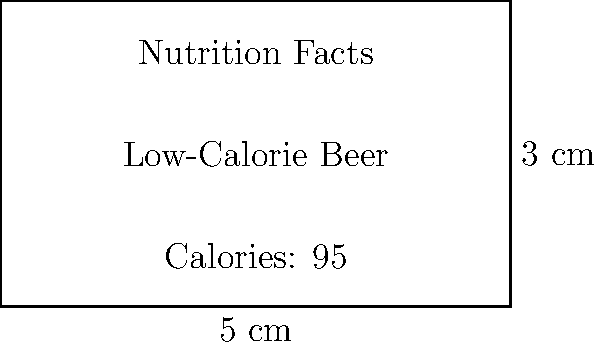A health-conscious bar-goer notices a new low-calorie beer with a rectangular nutrition label. The label measures 5 cm in width and 3 cm in height. What is the area of the nutrition label in square centimeters? To find the area of a rectangle, we multiply its length by its width. In this case:

1. Width of the label = 5 cm
2. Height of the label = 3 cm

Area = width $\times$ height
$$ A = 5 \text{ cm} \times 3 \text{ cm} = 15 \text{ cm}^2 $$

Therefore, the area of the nutrition label is 15 square centimeters.
Answer: $15 \text{ cm}^2$ 